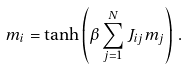Convert formula to latex. <formula><loc_0><loc_0><loc_500><loc_500>m _ { i } = \tanh \left ( \beta \sum _ { j = 1 } ^ { N } J _ { i j } m _ { j } \right ) \, .</formula> 